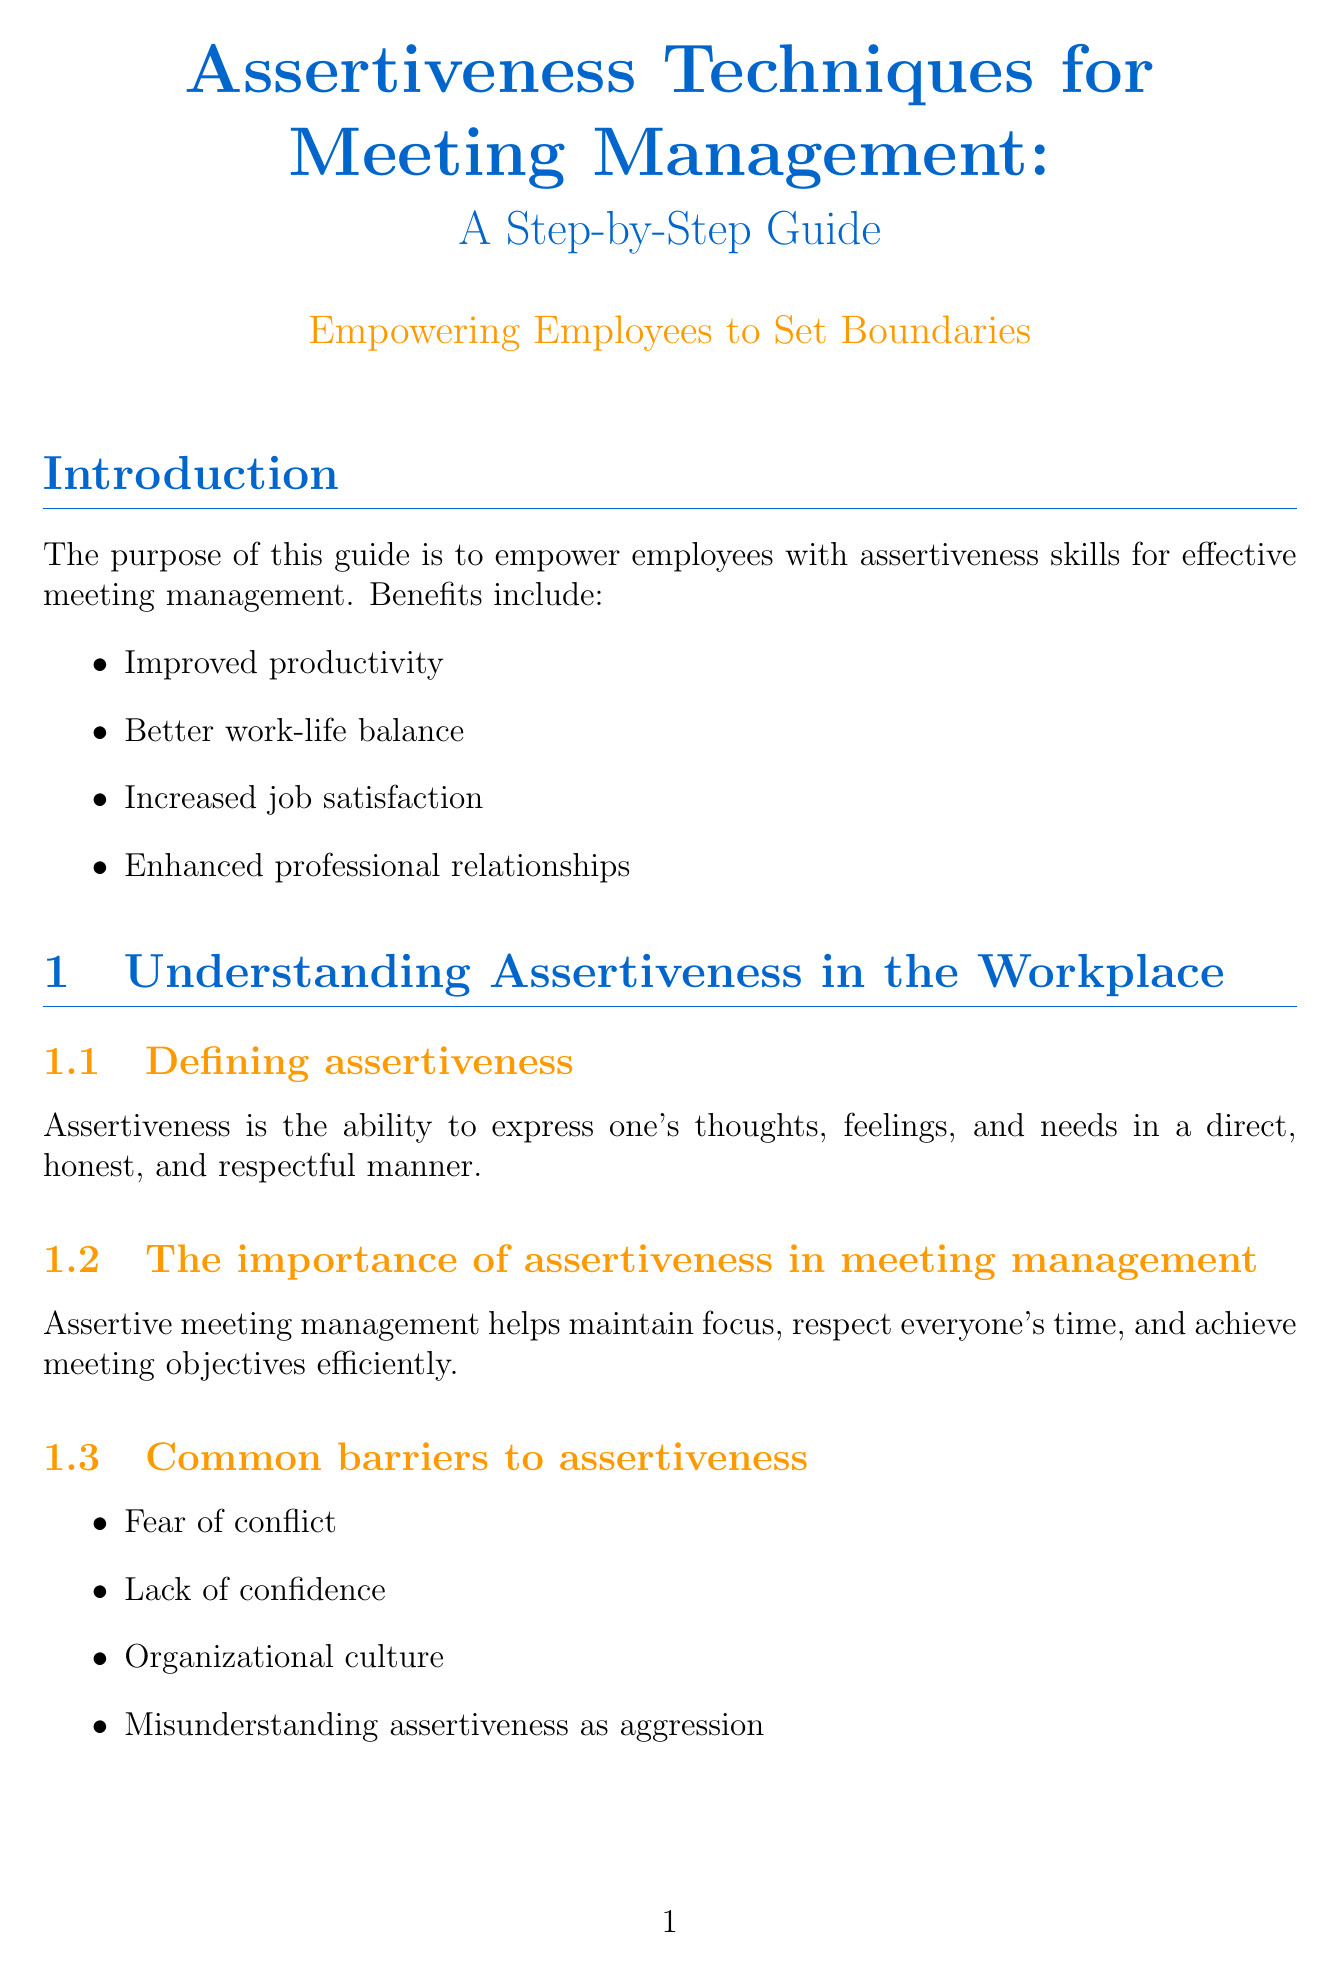What is the title of the document? The title of the document is found at the beginning and summarizes its focus on assertiveness in meetings.
Answer: Assertiveness Techniques for Meeting Management: A Step-by-Step Guide What is one benefit of assertiveness skills mentioned in the introduction? Benefits of assertiveness skills are listed in the introduction to highlight their importance in the workplace.
Answer: Improved productivity What is the primary method for declining meeting invitations outlined in the document? The document introduces a specific method to help employees decline meetings assertively.
Answer: DEAR method Name one common barrier to assertiveness discussed in the document. Barriers are listed in the section on understanding assertiveness, indicating challenges employees may face.
Answer: Fear of conflict What is a strategy for managing interruptions during meetings? Strategies for managing interruptions are provided to help assertively reclaim the floor when interrupted.
Answer: Phrases and body language What are the three key components of the 'DEAR method'? The document describes a structured approach for rejecting meeting invitations which includes specific components.
Answer: Describe, Express, Assert, Reinforce Which technique is suggested for effective time management during meetings? The document lists strategies for managing time within meetings effectively, one of which is a specific technique.
Answer: Pomodoro Technique What is the recommended reading mentioned for further understanding of assertiveness? The document suggests specific books that provide deeper insights into assertiveness and communication skills.
Answer: Crucial Conversations: Tools for Talking When Stakes Are High How can employees identify areas for improvement in their meeting habits? A section in the document provides guidance on evaluating self-assessment results regarding meeting practices.
Answer: Self-assessment questionnaire 